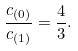<formula> <loc_0><loc_0><loc_500><loc_500>\frac { c _ { ( 0 ) } } { c _ { ( 1 ) } } = \frac { 4 } { 3 } .</formula> 